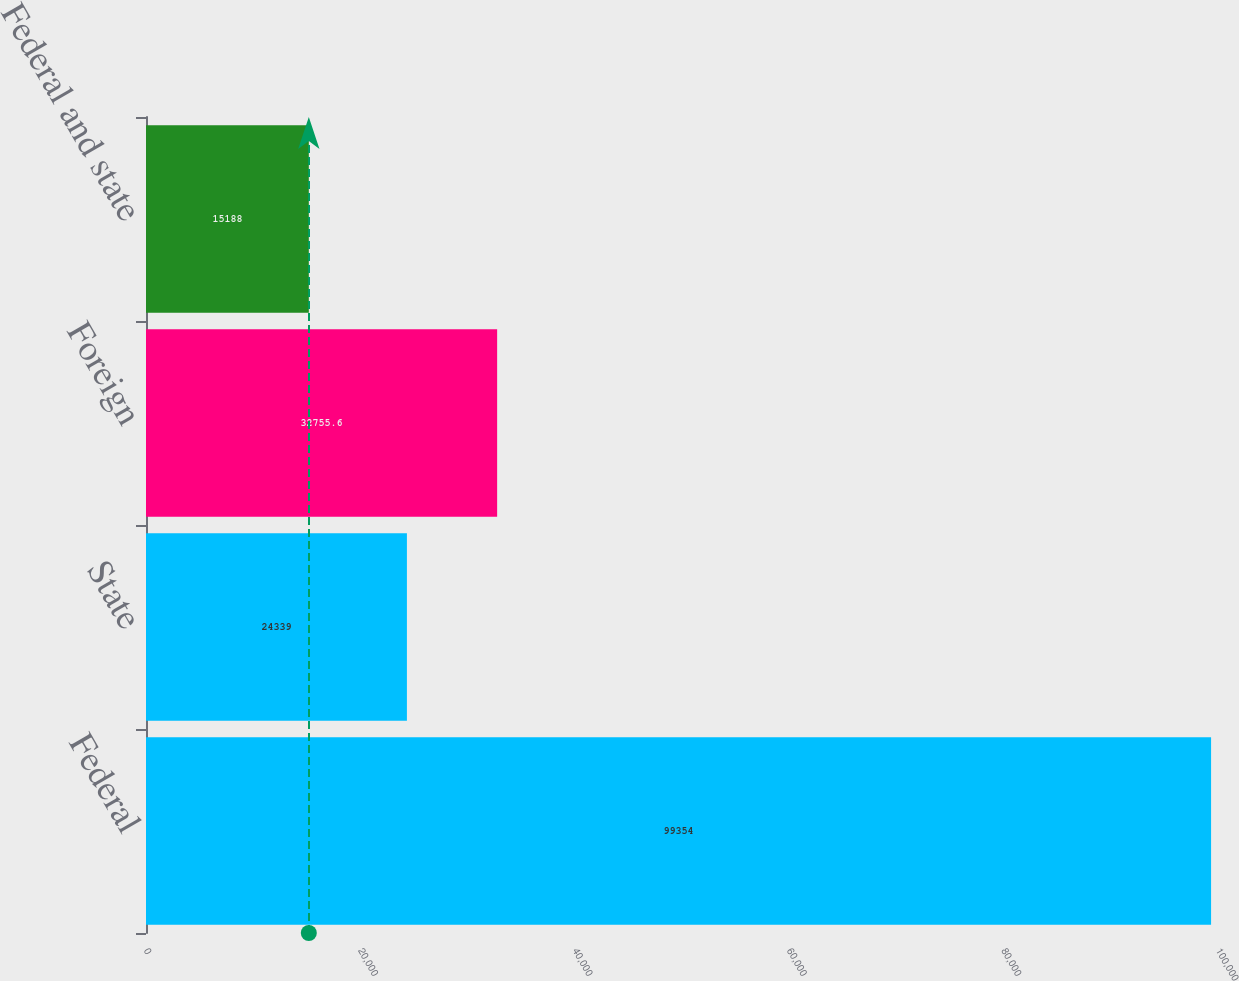Convert chart to OTSL. <chart><loc_0><loc_0><loc_500><loc_500><bar_chart><fcel>Federal<fcel>State<fcel>Foreign<fcel>Federal and state<nl><fcel>99354<fcel>24339<fcel>32755.6<fcel>15188<nl></chart> 